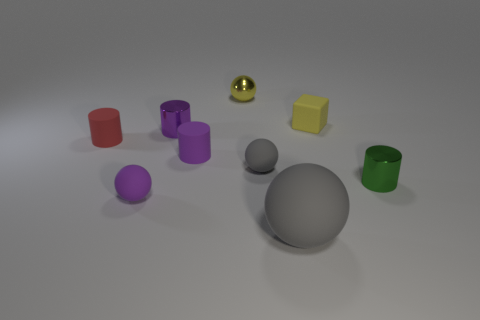Add 1 large brown matte spheres. How many objects exist? 10 Subtract all cylinders. How many objects are left? 5 Subtract 0 purple blocks. How many objects are left? 9 Subtract all red metal spheres. Subtract all matte cylinders. How many objects are left? 7 Add 4 small gray things. How many small gray things are left? 5 Add 4 large yellow spheres. How many large yellow spheres exist? 4 